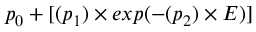<formula> <loc_0><loc_0><loc_500><loc_500>p _ { 0 } + [ ( p _ { 1 } ) \times e x p ( - ( p _ { 2 } ) \times E ) ]</formula> 